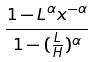Convert formula to latex. <formula><loc_0><loc_0><loc_500><loc_500>\frac { 1 - L ^ { \alpha } x ^ { - \alpha } } { 1 - ( \frac { L } { H } ) ^ { \alpha } }</formula> 